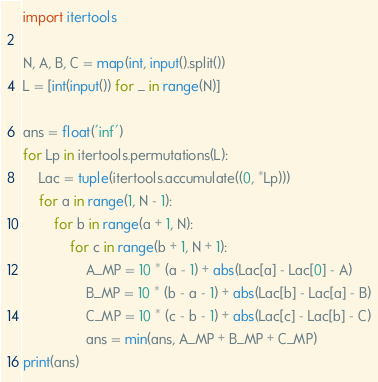<code> <loc_0><loc_0><loc_500><loc_500><_Python_>import itertools

N, A, B, C = map(int, input().split())
L = [int(input()) for _ in range(N)]

ans = float('inf')
for Lp in itertools.permutations(L):
    Lac = tuple(itertools.accumulate((0, *Lp)))
    for a in range(1, N - 1):
        for b in range(a + 1, N):
            for c in range(b + 1, N + 1):
                A_MP = 10 * (a - 1) + abs(Lac[a] - Lac[0] - A)
                B_MP = 10 * (b - a - 1) + abs(Lac[b] - Lac[a] - B)
                C_MP = 10 * (c - b - 1) + abs(Lac[c] - Lac[b] - C)
                ans = min(ans, A_MP + B_MP + C_MP)
print(ans)
</code> 